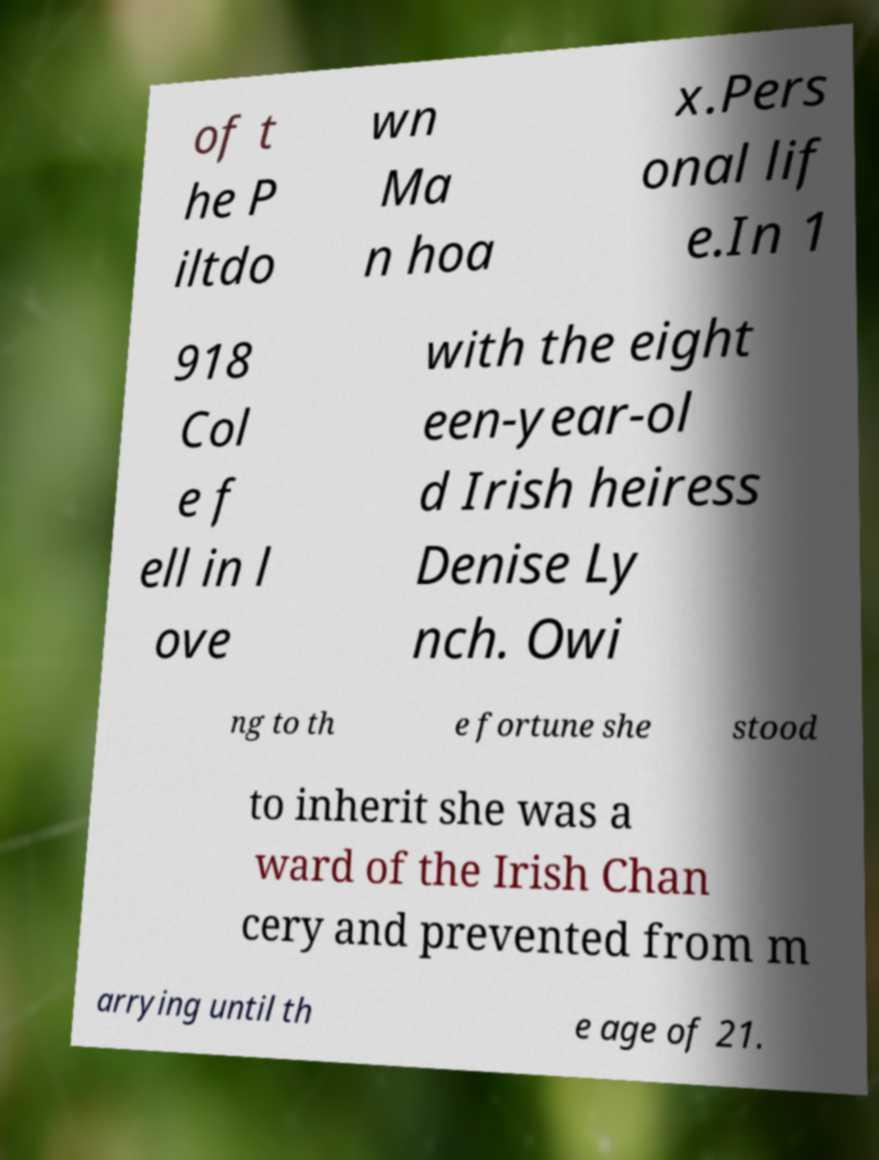What messages or text are displayed in this image? I need them in a readable, typed format. of t he P iltdo wn Ma n hoa x.Pers onal lif e.In 1 918 Col e f ell in l ove with the eight een-year-ol d Irish heiress Denise Ly nch. Owi ng to th e fortune she stood to inherit she was a ward of the Irish Chan cery and prevented from m arrying until th e age of 21. 